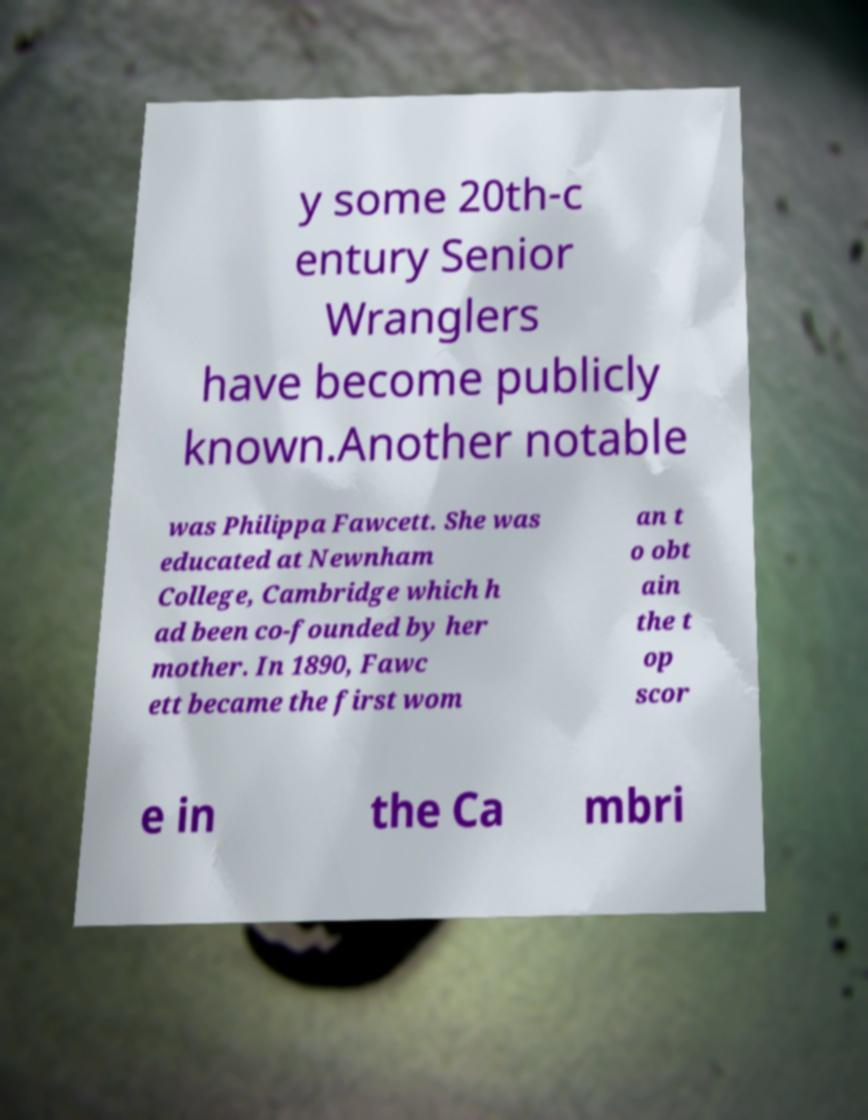Could you extract and type out the text from this image? y some 20th-c entury Senior Wranglers have become publicly known.Another notable was Philippa Fawcett. She was educated at Newnham College, Cambridge which h ad been co-founded by her mother. In 1890, Fawc ett became the first wom an t o obt ain the t op scor e in the Ca mbri 